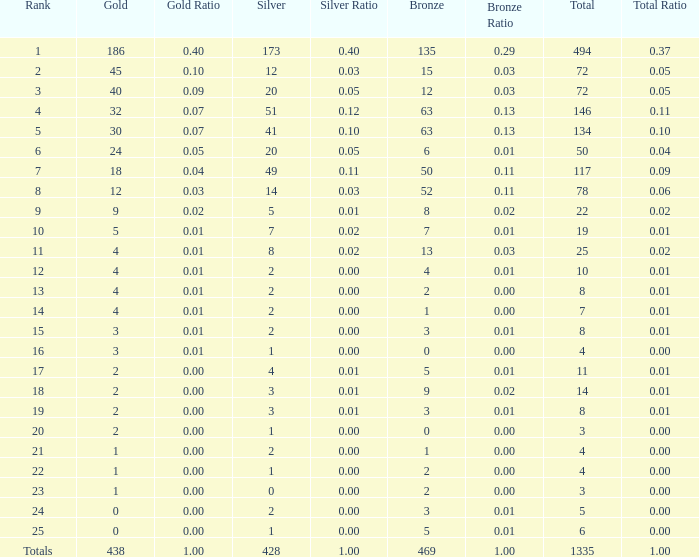Could you parse the entire table? {'header': ['Rank', 'Gold', 'Gold Ratio', 'Silver', 'Silver Ratio', 'Bronze', 'Bronze Ratio', 'Total', 'Total Ratio'], 'rows': [['1', '186', '0.40', '173', '0.40', '135', '0.29', '494', '0.37'], ['2', '45', '0.10', '12', '0.03', '15', '0.03', '72', '0.05'], ['3', '40', '0.09', '20', '0.05', '12', '0.03', '72', '0.05'], ['4', '32', '0.07', '51', '0.12', '63', '0.13', '146', '0.11'], ['5', '30', '0.07', '41', '0.10', '63', '0.13', '134', '0.10'], ['6', '24', '0.05', '20', '0.05', '6', '0.01', '50', '0.04'], ['7', '18', '0.04', '49', '0.11', '50', '0.11', '117', '0.09'], ['8', '12', '0.03', '14', '0.03', '52', '0.11', '78', '0.06'], ['9', '9', '0.02', '5', '0.01', '8', '0.02', '22', '0.02'], ['10', '5', '0.01', '7', '0.02', '7', '0.01', '19', '0.01'], ['11', '4', '0.01', '8', '0.02', '13', '0.03', '25', '0.02'], ['12', '4', '0.01', '2', '0.00', '4', '0.01', '10', '0.01'], ['13', '4', '0.01', '2', '0.00', '2', '0.00', '8', '0.01'], ['14', '4', '0.01', '2', '0.00', '1', '0.00', '7', '0.01'], ['15', '3', '0.01', '2', '0.00', '3', '0.01', '8', '0.01'], ['16', '3', '0.01', '1', '0.00', '0', '0.00', '4', '0.00'], ['17', '2', '0.00', '4', '0.01', '5', '0.01', '11', '0.01'], ['18', '2', '0.00', '3', '0.01', '9', '0.02', '14', '0.01'], ['19', '2', '0.00', '3', '0.01', '3', '0.01', '8', '0.01'], ['20', '2', '0.00', '1', '0.00', '0', '0.00', '3', '0.00'], ['21', '1', '0.00', '2', '0.00', '1', '0.00', '4', '0.00'], ['22', '1', '0.00', '1', '0.00', '2', '0.00', '4', '0.00'], ['23', '1', '0.00', '0', '0.00', '2', '0.00', '3', '0.00'], ['24', '0', '0.00', '2', '0.00', '3', '0.01', '5', '0.00'], ['25', '0', '0.00', '1', '0.00', '5', '0.01', '6', '0.00'], ['Totals', '438', '1.00', '428', '1.00', '469', '1.00', '1335', '1.00']]} What is the total amount of gold medals when there were more than 20 silvers and there were 135 bronze medals? 1.0. 